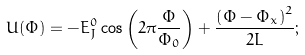Convert formula to latex. <formula><loc_0><loc_0><loc_500><loc_500>U ( \Phi ) = - E _ { J } ^ { 0 } \cos \left ( 2 \pi \frac { \Phi } { \Phi _ { 0 } } \right ) + \frac { \left ( \Phi - \Phi _ { x } \right ) ^ { 2 } } { 2 L } ;</formula> 